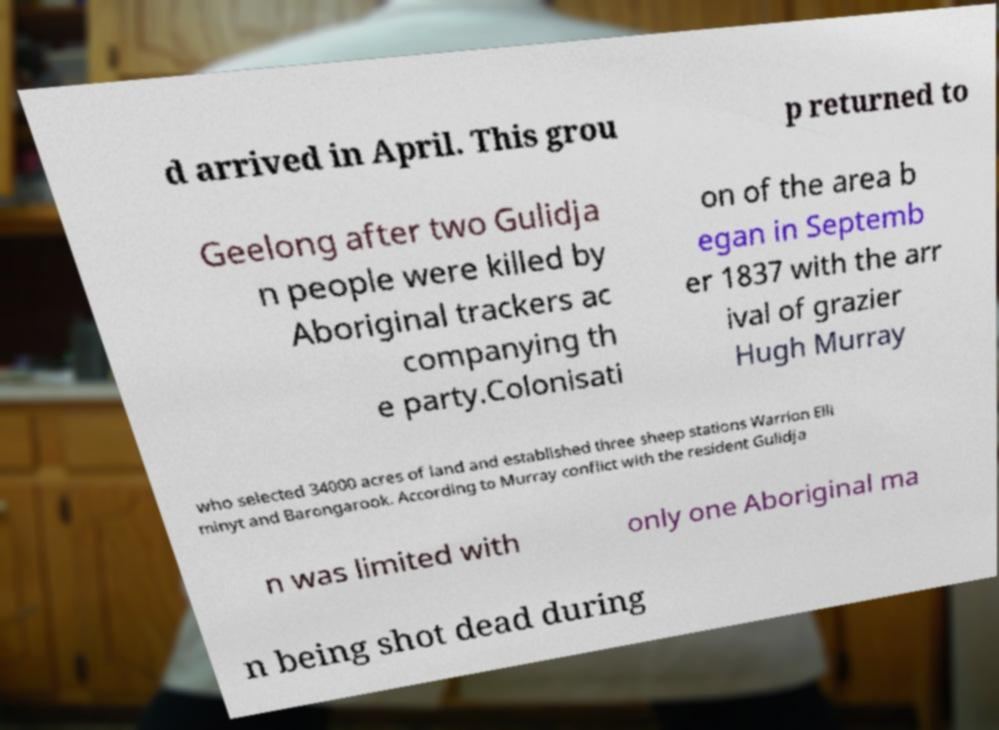Please read and relay the text visible in this image. What does it say? d arrived in April. This grou p returned to Geelong after two Gulidja n people were killed by Aboriginal trackers ac companying th e party.Colonisati on of the area b egan in Septemb er 1837 with the arr ival of grazier Hugh Murray who selected 34000 acres of land and established three sheep stations Warrion Elli minyt and Barongarook. According to Murray conflict with the resident Gulidja n was limited with only one Aboriginal ma n being shot dead during 